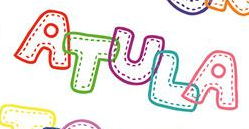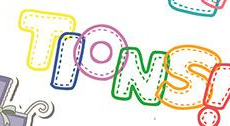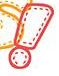What text appears in these images from left to right, separated by a semicolon? ATULA; TIONS; ! 